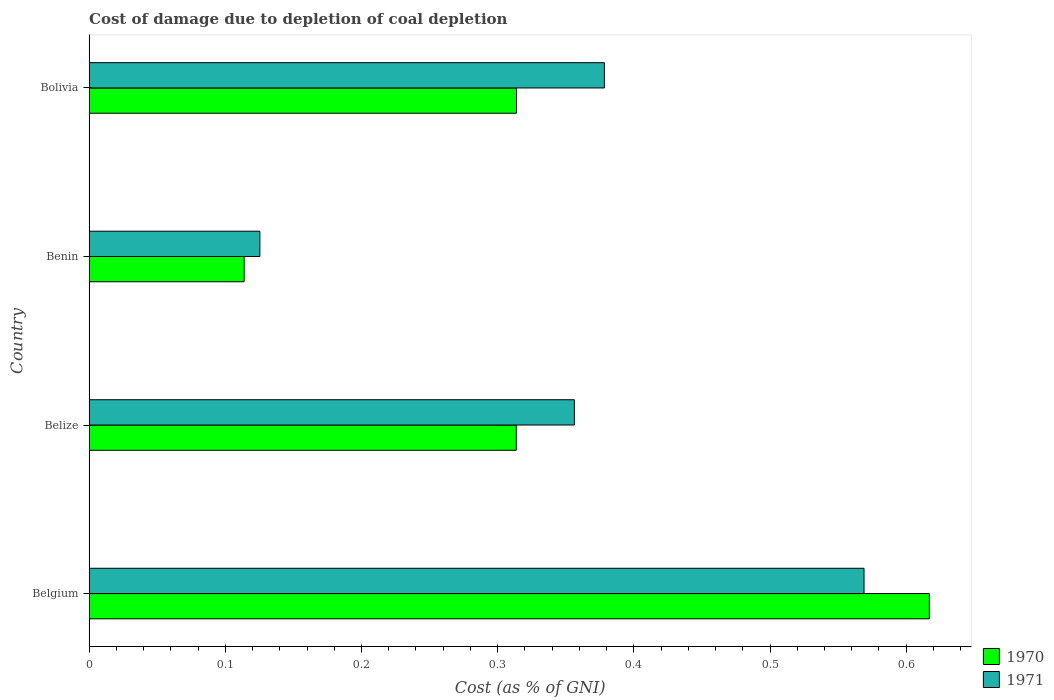How many groups of bars are there?
Keep it short and to the point. 4. How many bars are there on the 2nd tick from the top?
Give a very brief answer. 2. What is the label of the 3rd group of bars from the top?
Offer a very short reply. Belize. What is the cost of damage caused due to coal depletion in 1970 in Bolivia?
Give a very brief answer. 0.31. Across all countries, what is the maximum cost of damage caused due to coal depletion in 1971?
Give a very brief answer. 0.57. Across all countries, what is the minimum cost of damage caused due to coal depletion in 1971?
Ensure brevity in your answer.  0.13. In which country was the cost of damage caused due to coal depletion in 1971 minimum?
Make the answer very short. Benin. What is the total cost of damage caused due to coal depletion in 1970 in the graph?
Ensure brevity in your answer.  1.36. What is the difference between the cost of damage caused due to coal depletion in 1970 in Belize and that in Bolivia?
Ensure brevity in your answer.  -0. What is the difference between the cost of damage caused due to coal depletion in 1970 in Benin and the cost of damage caused due to coal depletion in 1971 in Belize?
Your answer should be compact. -0.24. What is the average cost of damage caused due to coal depletion in 1970 per country?
Offer a terse response. 0.34. What is the difference between the cost of damage caused due to coal depletion in 1970 and cost of damage caused due to coal depletion in 1971 in Belgium?
Keep it short and to the point. 0.05. In how many countries, is the cost of damage caused due to coal depletion in 1970 greater than 0.44 %?
Give a very brief answer. 1. What is the ratio of the cost of damage caused due to coal depletion in 1971 in Belize to that in Bolivia?
Make the answer very short. 0.94. Is the difference between the cost of damage caused due to coal depletion in 1970 in Belgium and Belize greater than the difference between the cost of damage caused due to coal depletion in 1971 in Belgium and Belize?
Your response must be concise. Yes. What is the difference between the highest and the second highest cost of damage caused due to coal depletion in 1971?
Make the answer very short. 0.19. What is the difference between the highest and the lowest cost of damage caused due to coal depletion in 1971?
Offer a very short reply. 0.44. Is the sum of the cost of damage caused due to coal depletion in 1971 in Belize and Bolivia greater than the maximum cost of damage caused due to coal depletion in 1970 across all countries?
Offer a terse response. Yes. What does the 1st bar from the top in Belgium represents?
Your response must be concise. 1971. What does the 2nd bar from the bottom in Belize represents?
Offer a terse response. 1971. Are all the bars in the graph horizontal?
Offer a very short reply. Yes. What is the difference between two consecutive major ticks on the X-axis?
Provide a short and direct response. 0.1. Does the graph contain any zero values?
Offer a very short reply. No. Where does the legend appear in the graph?
Ensure brevity in your answer.  Bottom right. How many legend labels are there?
Ensure brevity in your answer.  2. How are the legend labels stacked?
Give a very brief answer. Vertical. What is the title of the graph?
Provide a short and direct response. Cost of damage due to depletion of coal depletion. What is the label or title of the X-axis?
Your response must be concise. Cost (as % of GNI). What is the Cost (as % of GNI) of 1970 in Belgium?
Make the answer very short. 0.62. What is the Cost (as % of GNI) in 1971 in Belgium?
Provide a short and direct response. 0.57. What is the Cost (as % of GNI) in 1970 in Belize?
Provide a succinct answer. 0.31. What is the Cost (as % of GNI) in 1971 in Belize?
Provide a short and direct response. 0.36. What is the Cost (as % of GNI) in 1970 in Benin?
Offer a very short reply. 0.11. What is the Cost (as % of GNI) of 1971 in Benin?
Make the answer very short. 0.13. What is the Cost (as % of GNI) of 1970 in Bolivia?
Provide a short and direct response. 0.31. What is the Cost (as % of GNI) of 1971 in Bolivia?
Keep it short and to the point. 0.38. Across all countries, what is the maximum Cost (as % of GNI) of 1970?
Your answer should be very brief. 0.62. Across all countries, what is the maximum Cost (as % of GNI) in 1971?
Your answer should be compact. 0.57. Across all countries, what is the minimum Cost (as % of GNI) in 1970?
Provide a short and direct response. 0.11. Across all countries, what is the minimum Cost (as % of GNI) in 1971?
Provide a succinct answer. 0.13. What is the total Cost (as % of GNI) of 1970 in the graph?
Your response must be concise. 1.36. What is the total Cost (as % of GNI) of 1971 in the graph?
Ensure brevity in your answer.  1.43. What is the difference between the Cost (as % of GNI) of 1970 in Belgium and that in Belize?
Ensure brevity in your answer.  0.3. What is the difference between the Cost (as % of GNI) of 1971 in Belgium and that in Belize?
Offer a terse response. 0.21. What is the difference between the Cost (as % of GNI) in 1970 in Belgium and that in Benin?
Give a very brief answer. 0.5. What is the difference between the Cost (as % of GNI) of 1971 in Belgium and that in Benin?
Your response must be concise. 0.44. What is the difference between the Cost (as % of GNI) of 1970 in Belgium and that in Bolivia?
Provide a succinct answer. 0.3. What is the difference between the Cost (as % of GNI) of 1971 in Belgium and that in Bolivia?
Offer a terse response. 0.19. What is the difference between the Cost (as % of GNI) of 1970 in Belize and that in Benin?
Your response must be concise. 0.2. What is the difference between the Cost (as % of GNI) of 1971 in Belize and that in Benin?
Make the answer very short. 0.23. What is the difference between the Cost (as % of GNI) in 1970 in Belize and that in Bolivia?
Your answer should be very brief. -0. What is the difference between the Cost (as % of GNI) of 1971 in Belize and that in Bolivia?
Provide a short and direct response. -0.02. What is the difference between the Cost (as % of GNI) in 1971 in Benin and that in Bolivia?
Offer a very short reply. -0.25. What is the difference between the Cost (as % of GNI) of 1970 in Belgium and the Cost (as % of GNI) of 1971 in Belize?
Offer a very short reply. 0.26. What is the difference between the Cost (as % of GNI) in 1970 in Belgium and the Cost (as % of GNI) in 1971 in Benin?
Offer a very short reply. 0.49. What is the difference between the Cost (as % of GNI) of 1970 in Belgium and the Cost (as % of GNI) of 1971 in Bolivia?
Your answer should be compact. 0.24. What is the difference between the Cost (as % of GNI) of 1970 in Belize and the Cost (as % of GNI) of 1971 in Benin?
Provide a succinct answer. 0.19. What is the difference between the Cost (as % of GNI) of 1970 in Belize and the Cost (as % of GNI) of 1971 in Bolivia?
Your response must be concise. -0.06. What is the difference between the Cost (as % of GNI) of 1970 in Benin and the Cost (as % of GNI) of 1971 in Bolivia?
Provide a succinct answer. -0.26. What is the average Cost (as % of GNI) in 1970 per country?
Your answer should be compact. 0.34. What is the average Cost (as % of GNI) in 1971 per country?
Your answer should be very brief. 0.36. What is the difference between the Cost (as % of GNI) in 1970 and Cost (as % of GNI) in 1971 in Belgium?
Provide a succinct answer. 0.05. What is the difference between the Cost (as % of GNI) in 1970 and Cost (as % of GNI) in 1971 in Belize?
Your answer should be compact. -0.04. What is the difference between the Cost (as % of GNI) in 1970 and Cost (as % of GNI) in 1971 in Benin?
Your answer should be very brief. -0.01. What is the difference between the Cost (as % of GNI) in 1970 and Cost (as % of GNI) in 1971 in Bolivia?
Provide a short and direct response. -0.06. What is the ratio of the Cost (as % of GNI) in 1970 in Belgium to that in Belize?
Provide a short and direct response. 1.97. What is the ratio of the Cost (as % of GNI) of 1971 in Belgium to that in Belize?
Your response must be concise. 1.6. What is the ratio of the Cost (as % of GNI) in 1970 in Belgium to that in Benin?
Ensure brevity in your answer.  5.42. What is the ratio of the Cost (as % of GNI) of 1971 in Belgium to that in Benin?
Your response must be concise. 4.54. What is the ratio of the Cost (as % of GNI) in 1970 in Belgium to that in Bolivia?
Give a very brief answer. 1.97. What is the ratio of the Cost (as % of GNI) of 1971 in Belgium to that in Bolivia?
Offer a terse response. 1.5. What is the ratio of the Cost (as % of GNI) of 1970 in Belize to that in Benin?
Offer a very short reply. 2.76. What is the ratio of the Cost (as % of GNI) in 1971 in Belize to that in Benin?
Give a very brief answer. 2.84. What is the ratio of the Cost (as % of GNI) in 1971 in Belize to that in Bolivia?
Offer a very short reply. 0.94. What is the ratio of the Cost (as % of GNI) in 1970 in Benin to that in Bolivia?
Your answer should be very brief. 0.36. What is the ratio of the Cost (as % of GNI) in 1971 in Benin to that in Bolivia?
Keep it short and to the point. 0.33. What is the difference between the highest and the second highest Cost (as % of GNI) of 1970?
Offer a terse response. 0.3. What is the difference between the highest and the second highest Cost (as % of GNI) in 1971?
Give a very brief answer. 0.19. What is the difference between the highest and the lowest Cost (as % of GNI) of 1970?
Provide a succinct answer. 0.5. What is the difference between the highest and the lowest Cost (as % of GNI) in 1971?
Provide a succinct answer. 0.44. 